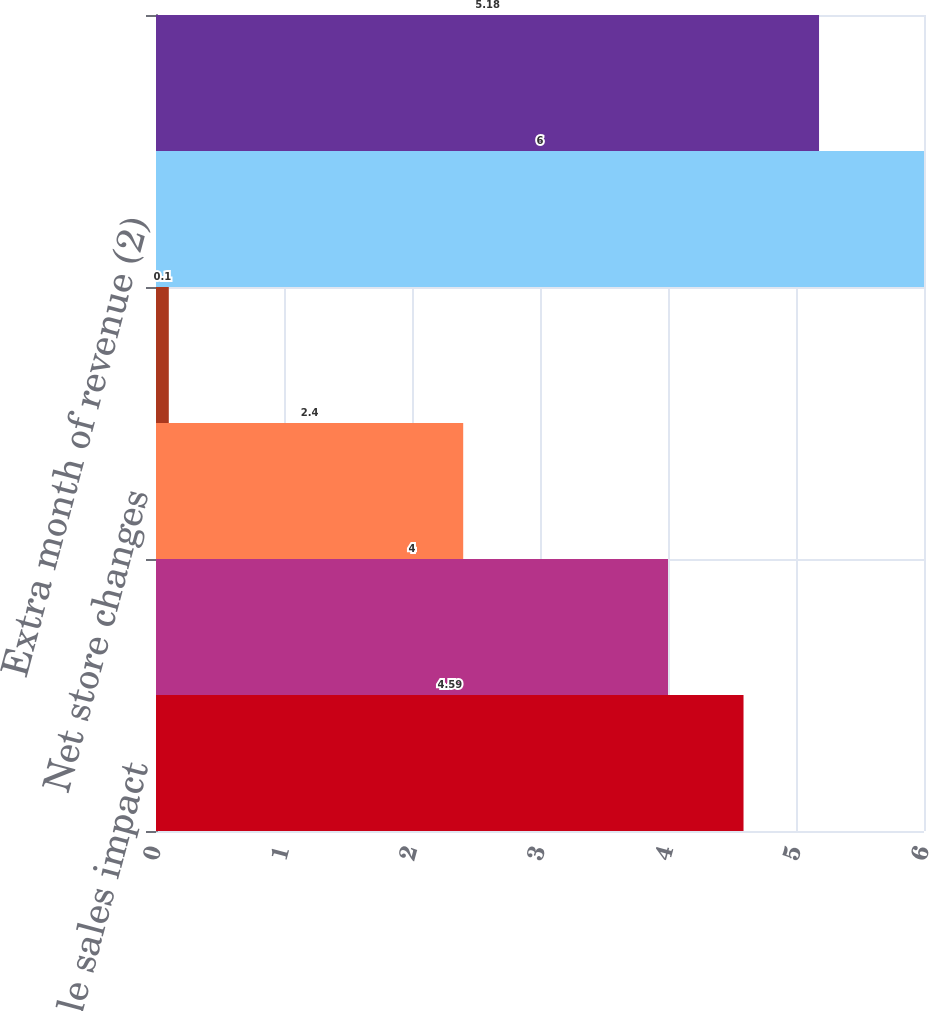<chart> <loc_0><loc_0><loc_500><loc_500><bar_chart><fcel>Comparable sales impact<fcel>Impact of foreign currency<fcel>Net store changes<fcel>Non-comparable sales (1)<fcel>Extra month of revenue (2)<fcel>Total revenue decrease<nl><fcel>4.59<fcel>4<fcel>2.4<fcel>0.1<fcel>6<fcel>5.18<nl></chart> 